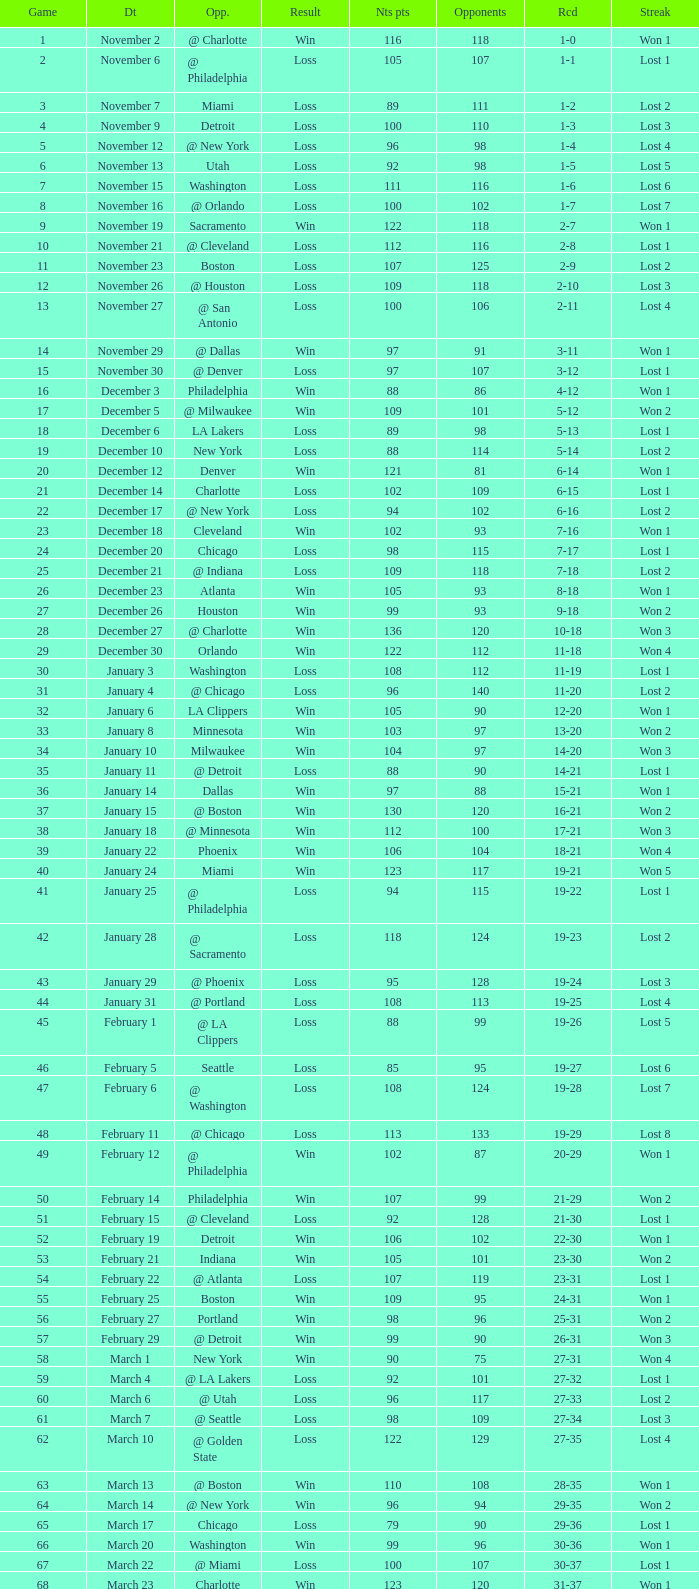How many games had fewer than 118 opponents and more than 109 net points with an opponent of Washington? 1.0. 